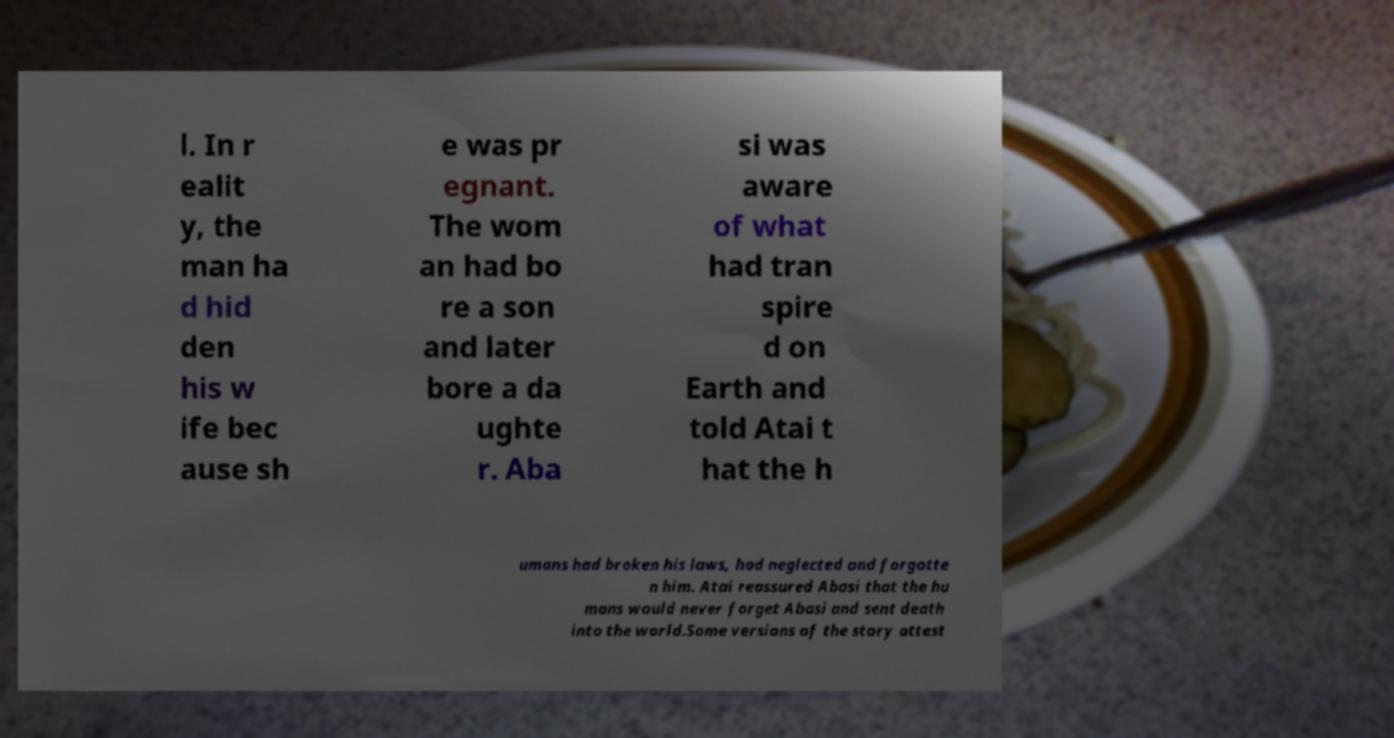Please read and relay the text visible in this image. What does it say? l. In r ealit y, the man ha d hid den his w ife bec ause sh e was pr egnant. The wom an had bo re a son and later bore a da ughte r. Aba si was aware of what had tran spire d on Earth and told Atai t hat the h umans had broken his laws, had neglected and forgotte n him. Atai reassured Abasi that the hu mans would never forget Abasi and sent death into the world.Some versions of the story attest 